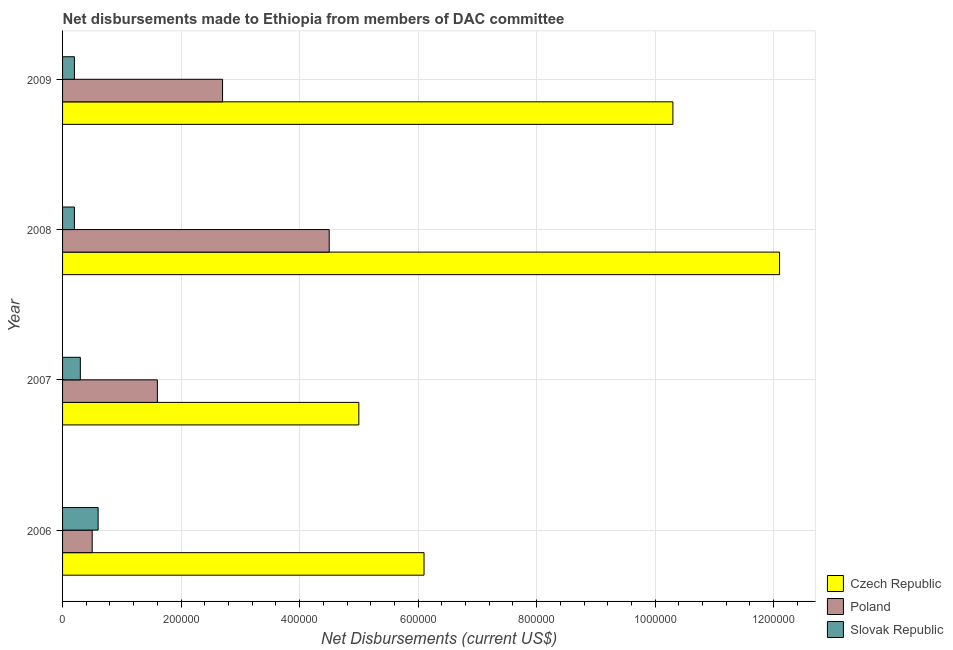How many different coloured bars are there?
Provide a succinct answer. 3. How many groups of bars are there?
Keep it short and to the point. 4. Are the number of bars on each tick of the Y-axis equal?
Make the answer very short. Yes. What is the label of the 2nd group of bars from the top?
Provide a short and direct response. 2008. What is the net disbursements made by czech republic in 2006?
Your answer should be compact. 6.10e+05. Across all years, what is the maximum net disbursements made by slovak republic?
Keep it short and to the point. 6.00e+04. Across all years, what is the minimum net disbursements made by czech republic?
Give a very brief answer. 5.00e+05. In which year was the net disbursements made by czech republic maximum?
Offer a terse response. 2008. What is the total net disbursements made by czech republic in the graph?
Offer a terse response. 3.35e+06. What is the difference between the net disbursements made by czech republic in 2007 and that in 2008?
Make the answer very short. -7.10e+05. What is the difference between the net disbursements made by slovak republic in 2006 and the net disbursements made by czech republic in 2009?
Your response must be concise. -9.70e+05. What is the average net disbursements made by poland per year?
Give a very brief answer. 2.32e+05. In the year 2009, what is the difference between the net disbursements made by slovak republic and net disbursements made by czech republic?
Keep it short and to the point. -1.01e+06. Is the net disbursements made by poland in 2006 less than that in 2009?
Your answer should be compact. Yes. Is the difference between the net disbursements made by czech republic in 2006 and 2009 greater than the difference between the net disbursements made by slovak republic in 2006 and 2009?
Give a very brief answer. No. What is the difference between the highest and the lowest net disbursements made by czech republic?
Your answer should be compact. 7.10e+05. In how many years, is the net disbursements made by poland greater than the average net disbursements made by poland taken over all years?
Provide a short and direct response. 2. What does the 1st bar from the top in 2006 represents?
Offer a terse response. Slovak Republic. What does the 2nd bar from the bottom in 2009 represents?
Provide a succinct answer. Poland. Are all the bars in the graph horizontal?
Your response must be concise. Yes. How many years are there in the graph?
Offer a very short reply. 4. Does the graph contain any zero values?
Offer a very short reply. No. Where does the legend appear in the graph?
Provide a short and direct response. Bottom right. What is the title of the graph?
Your answer should be compact. Net disbursements made to Ethiopia from members of DAC committee. Does "Social Protection" appear as one of the legend labels in the graph?
Provide a short and direct response. No. What is the label or title of the X-axis?
Your response must be concise. Net Disbursements (current US$). What is the Net Disbursements (current US$) in Poland in 2006?
Offer a very short reply. 5.00e+04. What is the Net Disbursements (current US$) in Slovak Republic in 2006?
Your answer should be compact. 6.00e+04. What is the Net Disbursements (current US$) of Czech Republic in 2007?
Provide a short and direct response. 5.00e+05. What is the Net Disbursements (current US$) of Poland in 2007?
Ensure brevity in your answer.  1.60e+05. What is the Net Disbursements (current US$) of Czech Republic in 2008?
Ensure brevity in your answer.  1.21e+06. What is the Net Disbursements (current US$) of Slovak Republic in 2008?
Provide a succinct answer. 2.00e+04. What is the Net Disbursements (current US$) in Czech Republic in 2009?
Offer a very short reply. 1.03e+06. Across all years, what is the maximum Net Disbursements (current US$) in Czech Republic?
Give a very brief answer. 1.21e+06. Across all years, what is the maximum Net Disbursements (current US$) in Poland?
Your answer should be compact. 4.50e+05. Across all years, what is the maximum Net Disbursements (current US$) in Slovak Republic?
Provide a succinct answer. 6.00e+04. Across all years, what is the minimum Net Disbursements (current US$) in Czech Republic?
Provide a succinct answer. 5.00e+05. Across all years, what is the minimum Net Disbursements (current US$) in Poland?
Keep it short and to the point. 5.00e+04. What is the total Net Disbursements (current US$) of Czech Republic in the graph?
Make the answer very short. 3.35e+06. What is the total Net Disbursements (current US$) in Poland in the graph?
Offer a very short reply. 9.30e+05. What is the total Net Disbursements (current US$) in Slovak Republic in the graph?
Provide a succinct answer. 1.30e+05. What is the difference between the Net Disbursements (current US$) in Slovak Republic in 2006 and that in 2007?
Your answer should be compact. 3.00e+04. What is the difference between the Net Disbursements (current US$) of Czech Republic in 2006 and that in 2008?
Offer a terse response. -6.00e+05. What is the difference between the Net Disbursements (current US$) of Poland in 2006 and that in 2008?
Your answer should be very brief. -4.00e+05. What is the difference between the Net Disbursements (current US$) in Slovak Republic in 2006 and that in 2008?
Make the answer very short. 4.00e+04. What is the difference between the Net Disbursements (current US$) of Czech Republic in 2006 and that in 2009?
Your response must be concise. -4.20e+05. What is the difference between the Net Disbursements (current US$) of Poland in 2006 and that in 2009?
Keep it short and to the point. -2.20e+05. What is the difference between the Net Disbursements (current US$) of Czech Republic in 2007 and that in 2008?
Make the answer very short. -7.10e+05. What is the difference between the Net Disbursements (current US$) of Slovak Republic in 2007 and that in 2008?
Your answer should be compact. 10000. What is the difference between the Net Disbursements (current US$) in Czech Republic in 2007 and that in 2009?
Provide a succinct answer. -5.30e+05. What is the difference between the Net Disbursements (current US$) in Czech Republic in 2008 and that in 2009?
Your answer should be very brief. 1.80e+05. What is the difference between the Net Disbursements (current US$) of Czech Republic in 2006 and the Net Disbursements (current US$) of Poland in 2007?
Ensure brevity in your answer.  4.50e+05. What is the difference between the Net Disbursements (current US$) in Czech Republic in 2006 and the Net Disbursements (current US$) in Slovak Republic in 2007?
Give a very brief answer. 5.80e+05. What is the difference between the Net Disbursements (current US$) in Czech Republic in 2006 and the Net Disbursements (current US$) in Poland in 2008?
Give a very brief answer. 1.60e+05. What is the difference between the Net Disbursements (current US$) in Czech Republic in 2006 and the Net Disbursements (current US$) in Slovak Republic in 2008?
Offer a very short reply. 5.90e+05. What is the difference between the Net Disbursements (current US$) of Poland in 2006 and the Net Disbursements (current US$) of Slovak Republic in 2008?
Offer a terse response. 3.00e+04. What is the difference between the Net Disbursements (current US$) of Czech Republic in 2006 and the Net Disbursements (current US$) of Slovak Republic in 2009?
Ensure brevity in your answer.  5.90e+05. What is the difference between the Net Disbursements (current US$) in Czech Republic in 2007 and the Net Disbursements (current US$) in Poland in 2008?
Your answer should be compact. 5.00e+04. What is the difference between the Net Disbursements (current US$) in Czech Republic in 2007 and the Net Disbursements (current US$) in Poland in 2009?
Ensure brevity in your answer.  2.30e+05. What is the difference between the Net Disbursements (current US$) in Czech Republic in 2008 and the Net Disbursements (current US$) in Poland in 2009?
Your response must be concise. 9.40e+05. What is the difference between the Net Disbursements (current US$) of Czech Republic in 2008 and the Net Disbursements (current US$) of Slovak Republic in 2009?
Provide a short and direct response. 1.19e+06. What is the average Net Disbursements (current US$) in Czech Republic per year?
Give a very brief answer. 8.38e+05. What is the average Net Disbursements (current US$) in Poland per year?
Offer a very short reply. 2.32e+05. What is the average Net Disbursements (current US$) in Slovak Republic per year?
Ensure brevity in your answer.  3.25e+04. In the year 2006, what is the difference between the Net Disbursements (current US$) in Czech Republic and Net Disbursements (current US$) in Poland?
Provide a succinct answer. 5.60e+05. In the year 2007, what is the difference between the Net Disbursements (current US$) in Czech Republic and Net Disbursements (current US$) in Slovak Republic?
Keep it short and to the point. 4.70e+05. In the year 2008, what is the difference between the Net Disbursements (current US$) of Czech Republic and Net Disbursements (current US$) of Poland?
Make the answer very short. 7.60e+05. In the year 2008, what is the difference between the Net Disbursements (current US$) of Czech Republic and Net Disbursements (current US$) of Slovak Republic?
Your answer should be very brief. 1.19e+06. In the year 2008, what is the difference between the Net Disbursements (current US$) in Poland and Net Disbursements (current US$) in Slovak Republic?
Your response must be concise. 4.30e+05. In the year 2009, what is the difference between the Net Disbursements (current US$) of Czech Republic and Net Disbursements (current US$) of Poland?
Ensure brevity in your answer.  7.60e+05. In the year 2009, what is the difference between the Net Disbursements (current US$) in Czech Republic and Net Disbursements (current US$) in Slovak Republic?
Offer a very short reply. 1.01e+06. In the year 2009, what is the difference between the Net Disbursements (current US$) in Poland and Net Disbursements (current US$) in Slovak Republic?
Ensure brevity in your answer.  2.50e+05. What is the ratio of the Net Disbursements (current US$) of Czech Republic in 2006 to that in 2007?
Ensure brevity in your answer.  1.22. What is the ratio of the Net Disbursements (current US$) of Poland in 2006 to that in 2007?
Provide a succinct answer. 0.31. What is the ratio of the Net Disbursements (current US$) in Slovak Republic in 2006 to that in 2007?
Offer a terse response. 2. What is the ratio of the Net Disbursements (current US$) of Czech Republic in 2006 to that in 2008?
Offer a very short reply. 0.5. What is the ratio of the Net Disbursements (current US$) of Czech Republic in 2006 to that in 2009?
Your answer should be very brief. 0.59. What is the ratio of the Net Disbursements (current US$) of Poland in 2006 to that in 2009?
Your answer should be compact. 0.19. What is the ratio of the Net Disbursements (current US$) in Slovak Republic in 2006 to that in 2009?
Provide a succinct answer. 3. What is the ratio of the Net Disbursements (current US$) in Czech Republic in 2007 to that in 2008?
Provide a succinct answer. 0.41. What is the ratio of the Net Disbursements (current US$) in Poland in 2007 to that in 2008?
Your answer should be very brief. 0.36. What is the ratio of the Net Disbursements (current US$) in Slovak Republic in 2007 to that in 2008?
Provide a succinct answer. 1.5. What is the ratio of the Net Disbursements (current US$) of Czech Republic in 2007 to that in 2009?
Make the answer very short. 0.49. What is the ratio of the Net Disbursements (current US$) of Poland in 2007 to that in 2009?
Make the answer very short. 0.59. What is the ratio of the Net Disbursements (current US$) in Slovak Republic in 2007 to that in 2009?
Ensure brevity in your answer.  1.5. What is the ratio of the Net Disbursements (current US$) in Czech Republic in 2008 to that in 2009?
Your answer should be very brief. 1.17. What is the ratio of the Net Disbursements (current US$) in Poland in 2008 to that in 2009?
Provide a succinct answer. 1.67. What is the ratio of the Net Disbursements (current US$) of Slovak Republic in 2008 to that in 2009?
Give a very brief answer. 1. What is the difference between the highest and the second highest Net Disbursements (current US$) in Poland?
Keep it short and to the point. 1.80e+05. What is the difference between the highest and the second highest Net Disbursements (current US$) of Slovak Republic?
Provide a succinct answer. 3.00e+04. What is the difference between the highest and the lowest Net Disbursements (current US$) in Czech Republic?
Provide a short and direct response. 7.10e+05. What is the difference between the highest and the lowest Net Disbursements (current US$) in Poland?
Keep it short and to the point. 4.00e+05. 